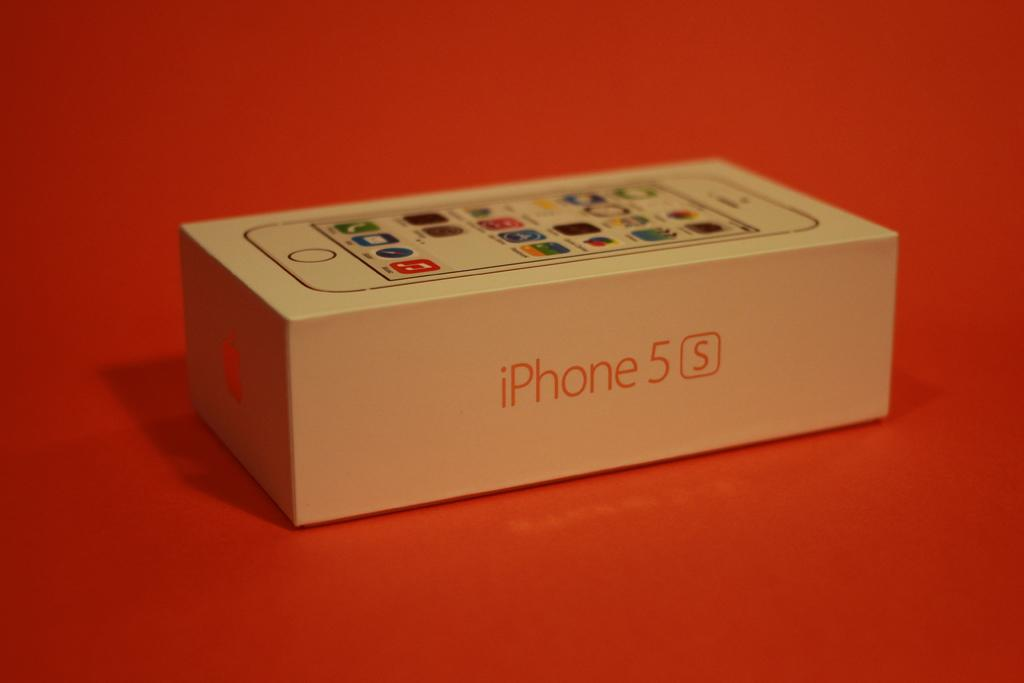<image>
Relay a brief, clear account of the picture shown. A box with iPhone 5 S typed on the side. 